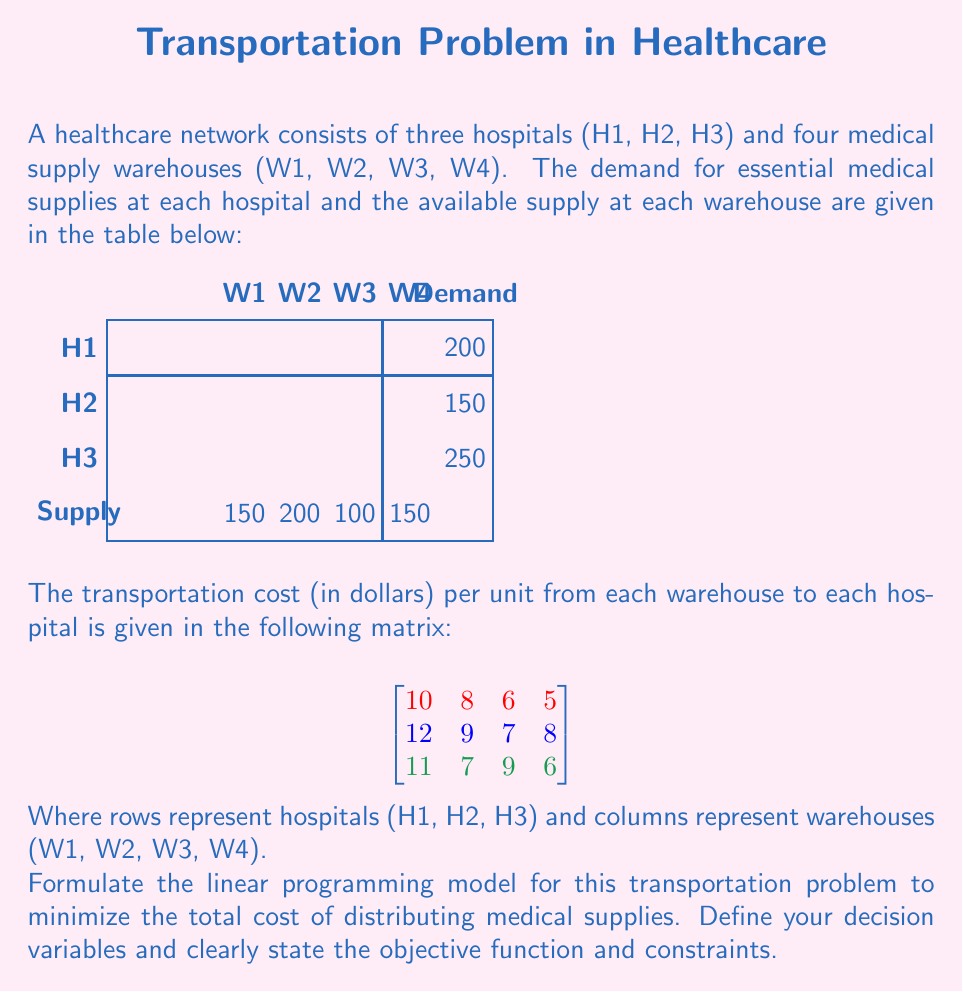Solve this math problem. To formulate the linear programming model for this transportation problem, we'll follow these steps:

1. Define decision variables:
Let $x_{ij}$ be the number of units transported from warehouse $i$ to hospital $j$, where $i = 1, 2, 3, 4$ and $j = 1, 2, 3$.

2. Formulate the objective function:
The goal is to minimize the total transportation cost. We multiply each decision variable by its corresponding cost and sum them all:

$$\text{Minimize } Z = 10x_{11} + 8x_{21} + 6x_{31} + 5x_{41} + 12x_{12} + 9x_{22} + 7x_{32} + 8x_{42} + 11x_{13} + 7x_{23} + 9x_{33} + 6x_{43}$$

3. Define the constraints:

a) Supply constraints (for each warehouse):
$$x_{11} + x_{12} + x_{13} \leq 150$$
$$x_{21} + x_{22} + x_{23} \leq 200$$
$$x_{31} + x_{32} + x_{33} \leq 100$$
$$x_{41} + x_{42} + x_{43} \leq 150$$

b) Demand constraints (for each hospital):
$$x_{11} + x_{21} + x_{31} + x_{41} = 200$$
$$x_{12} + x_{22} + x_{32} + x_{42} = 150$$
$$x_{13} + x_{23} + x_{33} + x_{43} = 250$$

c) Non-negativity constraints:
$$x_{ij} \geq 0 \text{ for all } i \text{ and } j$$

4. The complete linear programming model:

$$
\begin{align*}
\text{Minimize } Z &= 10x_{11} + 8x_{21} + 6x_{31} + 5x_{41} + 12x_{12} + 9x_{22} + 7x_{32} + 8x_{42} + 11x_{13} + 7x_{23} + 9x_{33} + 6x_{43} \\
\text{Subject to:} \\
x_{11} + x_{12} + x_{13} &\leq 150 \\
x_{21} + x_{22} + x_{23} &\leq 200 \\
x_{31} + x_{32} + x_{33} &\leq 100 \\
x_{41} + x_{42} + x_{43} &\leq 150 \\
x_{11} + x_{21} + x_{31} + x_{41} &= 200 \\
x_{12} + x_{22} + x_{32} + x_{42} &= 150 \\
x_{13} + x_{23} + x_{33} + x_{43} &= 250 \\
x_{ij} &\geq 0 \text{ for all } i \text{ and } j
\end{align*}
$$

This formulation represents the complete linear programming model for the given transportation problem.
Answer: $$
\begin{align*}
\text{Min } Z &= \sum_{i=1}^4 \sum_{j=1}^3 c_{ij}x_{ij} \\
\text{s.t. } &\sum_{j=1}^3 x_{ij} \leq s_i, \quad i = 1,2,3,4 \\
&\sum_{i=1}^4 x_{ij} = d_j, \quad j = 1,2,3 \\
&x_{ij} \geq 0, \quad \forall i,j
\end{align*}
$$
Where $c_{ij}$ is the cost, $s_i$ is supply, and $d_j$ is demand. 